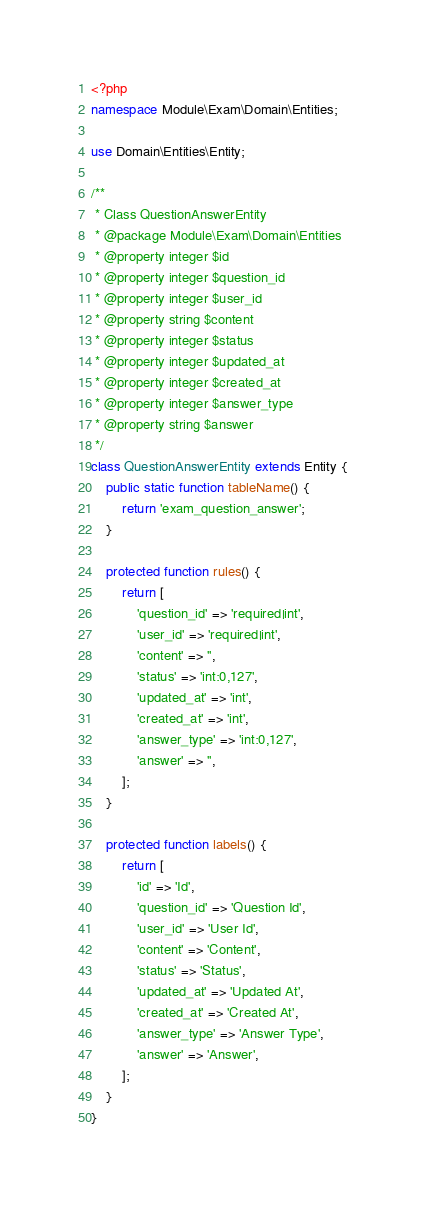Convert code to text. <code><loc_0><loc_0><loc_500><loc_500><_PHP_><?php
namespace Module\Exam\Domain\Entities;

use Domain\Entities\Entity;

/**
 * Class QuestionAnswerEntity
 * @package Module\Exam\Domain\Entities
 * @property integer $id
 * @property integer $question_id
 * @property integer $user_id
 * @property string $content
 * @property integer $status
 * @property integer $updated_at
 * @property integer $created_at
 * @property integer $answer_type
 * @property string $answer
 */
class QuestionAnswerEntity extends Entity {
	public static function tableName() {
        return 'exam_question_answer';
    }

    protected function rules() {
        return [
            'question_id' => 'required|int',
            'user_id' => 'required|int',
            'content' => '',
            'status' => 'int:0,127',
            'updated_at' => 'int',
            'created_at' => 'int',
            'answer_type' => 'int:0,127',
            'answer' => '',
        ];
    }

    protected function labels() {
        return [
            'id' => 'Id',
            'question_id' => 'Question Id',
            'user_id' => 'User Id',
            'content' => 'Content',
            'status' => 'Status',
            'updated_at' => 'Updated At',
            'created_at' => 'Created At',
            'answer_type' => 'Answer Type',
            'answer' => 'Answer',
        ];
    }
}</code> 